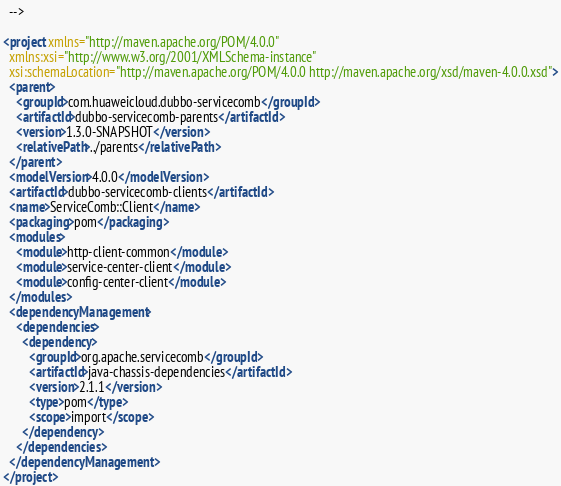<code> <loc_0><loc_0><loc_500><loc_500><_XML_>  -->

<project xmlns="http://maven.apache.org/POM/4.0.0"
  xmlns:xsi="http://www.w3.org/2001/XMLSchema-instance"
  xsi:schemaLocation="http://maven.apache.org/POM/4.0.0 http://maven.apache.org/xsd/maven-4.0.0.xsd">
  <parent>
    <groupId>com.huaweicloud.dubbo-servicecomb</groupId>
    <artifactId>dubbo-servicecomb-parents</artifactId>
    <version>1.3.0-SNAPSHOT</version>
    <relativePath>../parents</relativePath>
  </parent>
  <modelVersion>4.0.0</modelVersion>
  <artifactId>dubbo-servicecomb-clients</artifactId>
  <name>ServiceComb::Client</name>
  <packaging>pom</packaging>
  <modules>
    <module>http-client-common</module>
    <module>service-center-client</module>
    <module>config-center-client</module>
  </modules>
  <dependencyManagement>
    <dependencies>
      <dependency>
        <groupId>org.apache.servicecomb</groupId>
        <artifactId>java-chassis-dependencies</artifactId>
        <version>2.1.1</version>
        <type>pom</type>
        <scope>import</scope>
      </dependency>
    </dependencies>
  </dependencyManagement>
</project>
</code> 